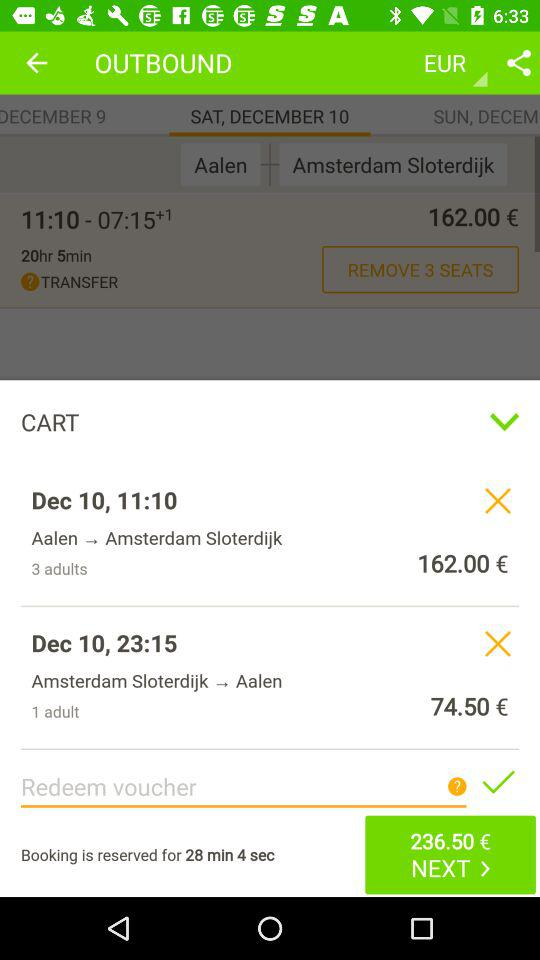How much is the total price of the tickets?
Answer the question using a single word or phrase. 236.50 € 